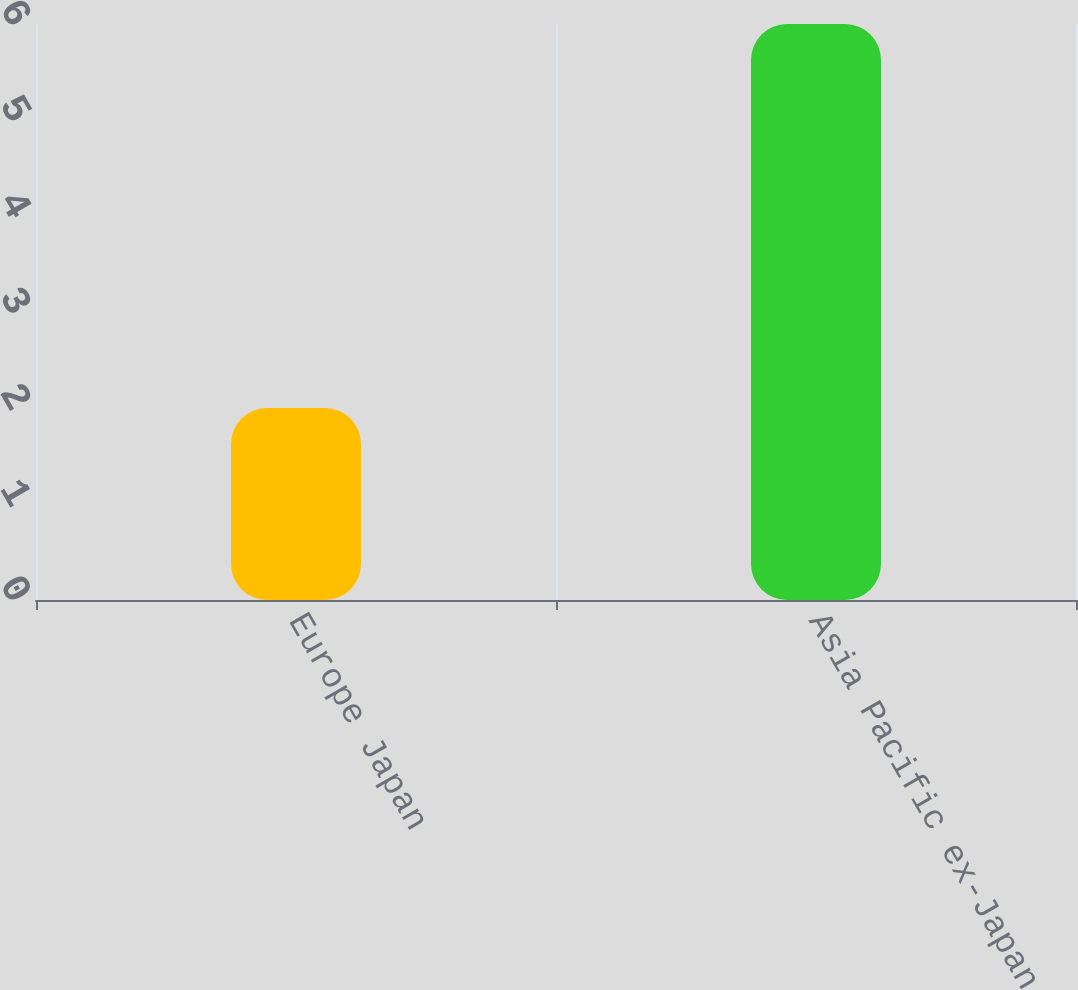Convert chart to OTSL. <chart><loc_0><loc_0><loc_500><loc_500><bar_chart><fcel>Europe Japan<fcel>Asia Pacific ex-Japan<nl><fcel>2<fcel>6<nl></chart> 